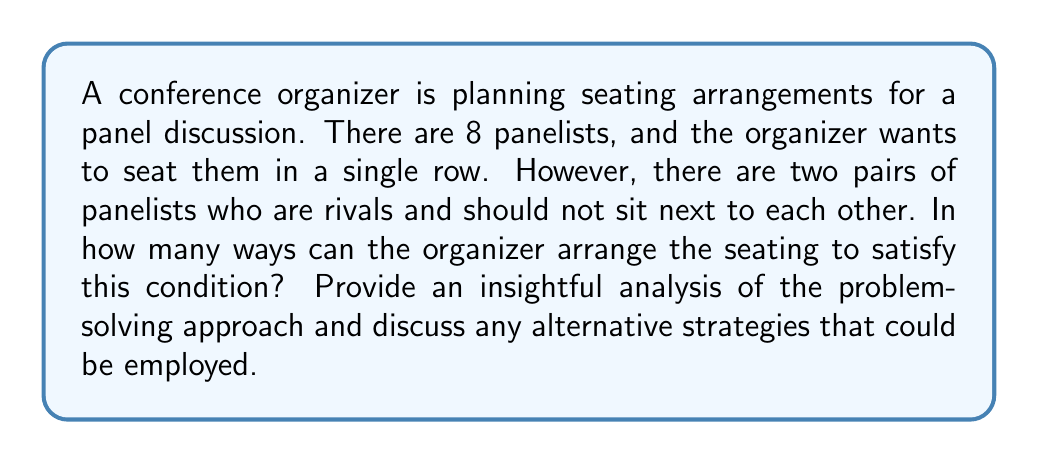Solve this math problem. Let's approach this problem step-by-step using the principle of inclusion-exclusion:

1) First, calculate the total number of ways to arrange 8 panelists without any restrictions:
   $$8! = 40,320$$

2) Now, we need to subtract the arrangements where the rivals sit next to each other. Let's call the two pairs of rivals (A,B) and (C,D).

3) For each pair of rivals, we can consider them as a single unit. So we now have 7 units to arrange (the pair and 6 other panelists).

4) For each of these arrangements, the rivals within the pair can be arranged in 2 ways.

5) So, for each pair of rivals, the number of "bad" arrangements is:
   $$7! \times 2 = 10,080$$

6) However, if we simply subtract these "bad" arrangements for both pairs, we'll have subtracted the cases where both pairs of rivals are sitting together twice. We need to add these back.

7) To count arrangements where both pairs are sitting together, we can consider each pair as a unit, giving us 6 units to arrange:
   $$6! \times 2 \times 2 = 1,440$$

8) Applying the principle of inclusion-exclusion, our final count is:
   $$8! - (7! \times 2 \times 2) + 6! \times 2 \times 2 = 40,320 - 20,160 + 1,440 = 21,600$$

Alternative strategy:
We could also solve this using complementary counting. We could count the number of ways to arrange the panelists where at least one pair of rivals is seated together, and subtract this from the total number of arrangements. This approach might be more intuitive for some problem solvers.
Answer: $$21,600$$ 